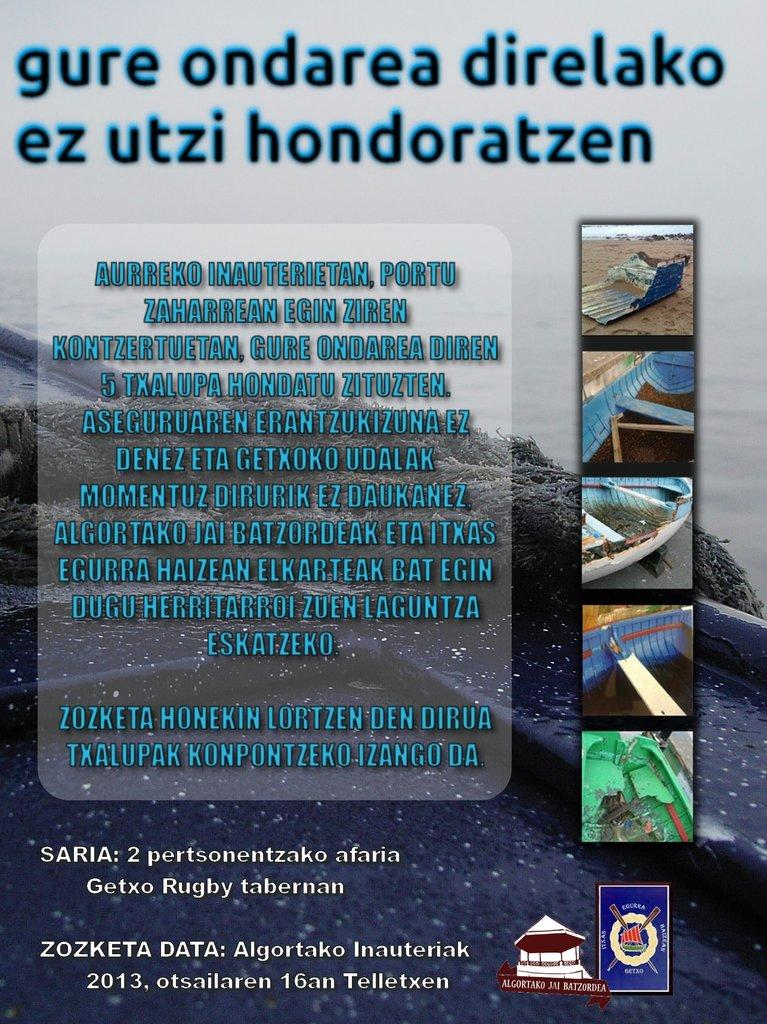Provide a one-sentence caption for the provided image. A poster that says gure ondarea direlako ez utzi hondoratzen. 